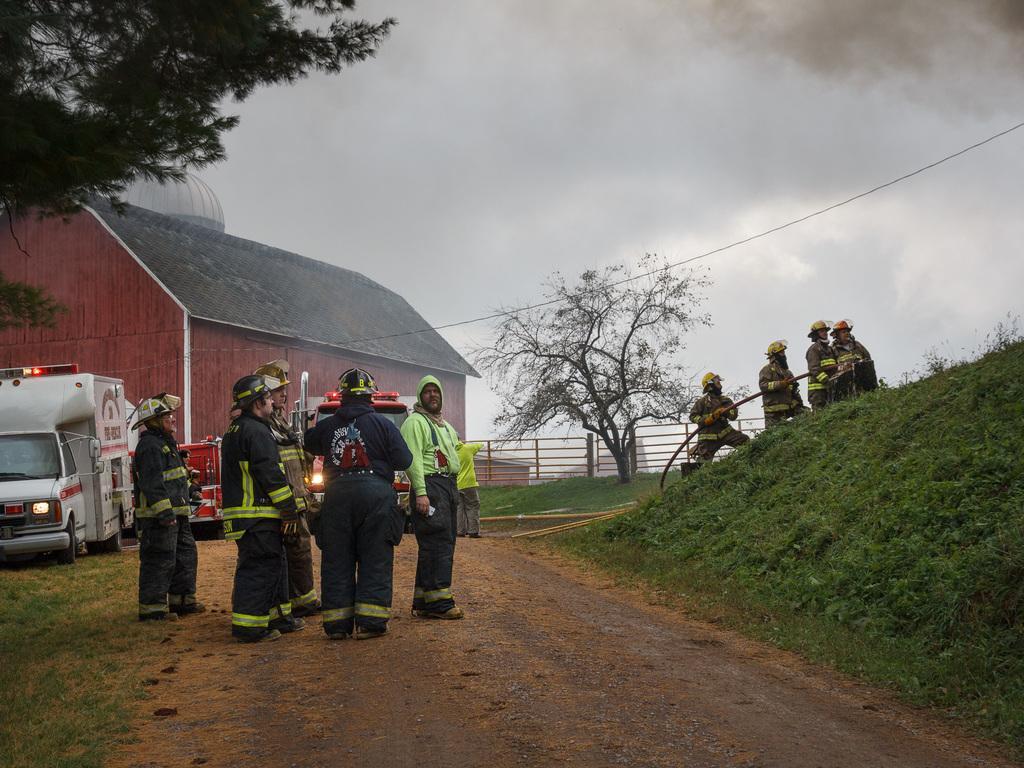Describe this image in one or two sentences. Here in this picture we can see groups of people standing over a place with fire suits on them and we can also see helmets on them, the group present on the right side is holding a pipe in their hand and we can see grass present on the ground all over there, behind them we can see a truck present over there and we can also see a shed present and in the middle we can see a railing present and we can see trees present here and there and we can also see clouds in the sky. 